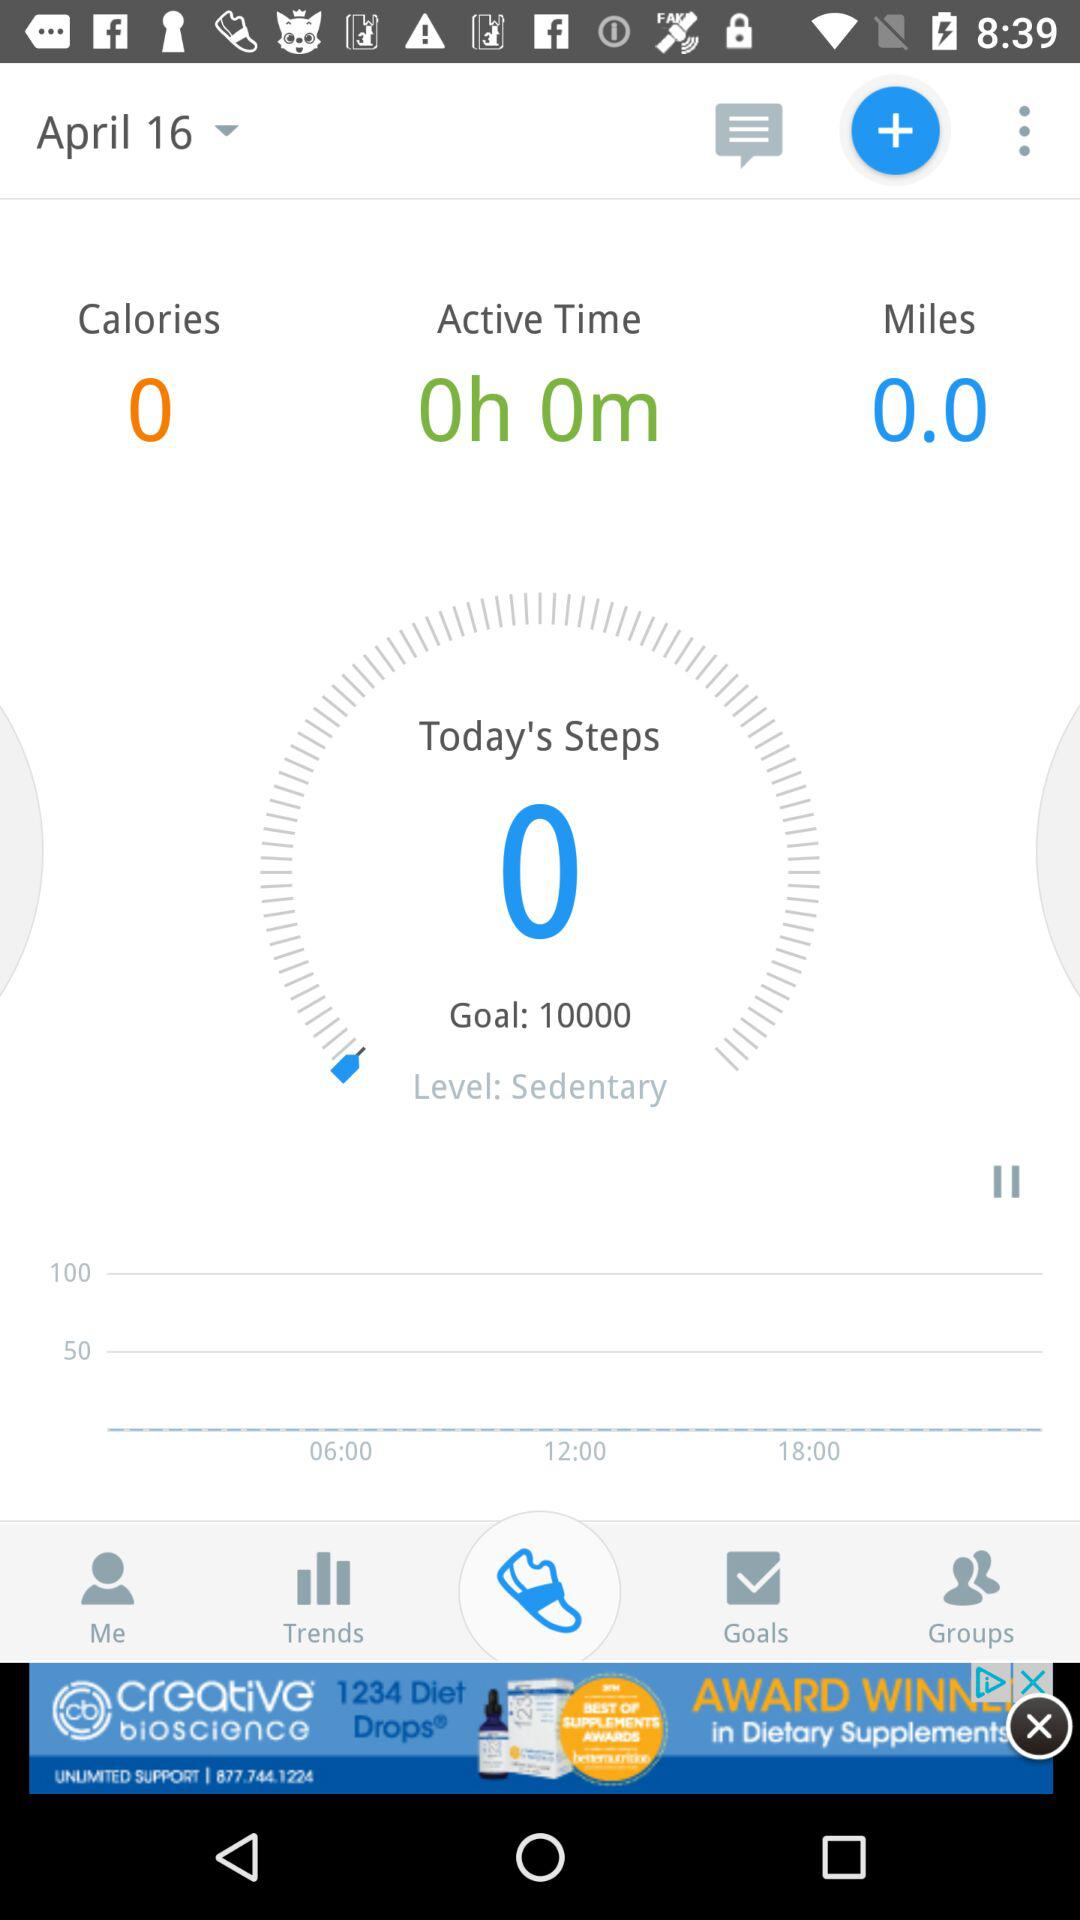What is the level? The level is sedentary. 